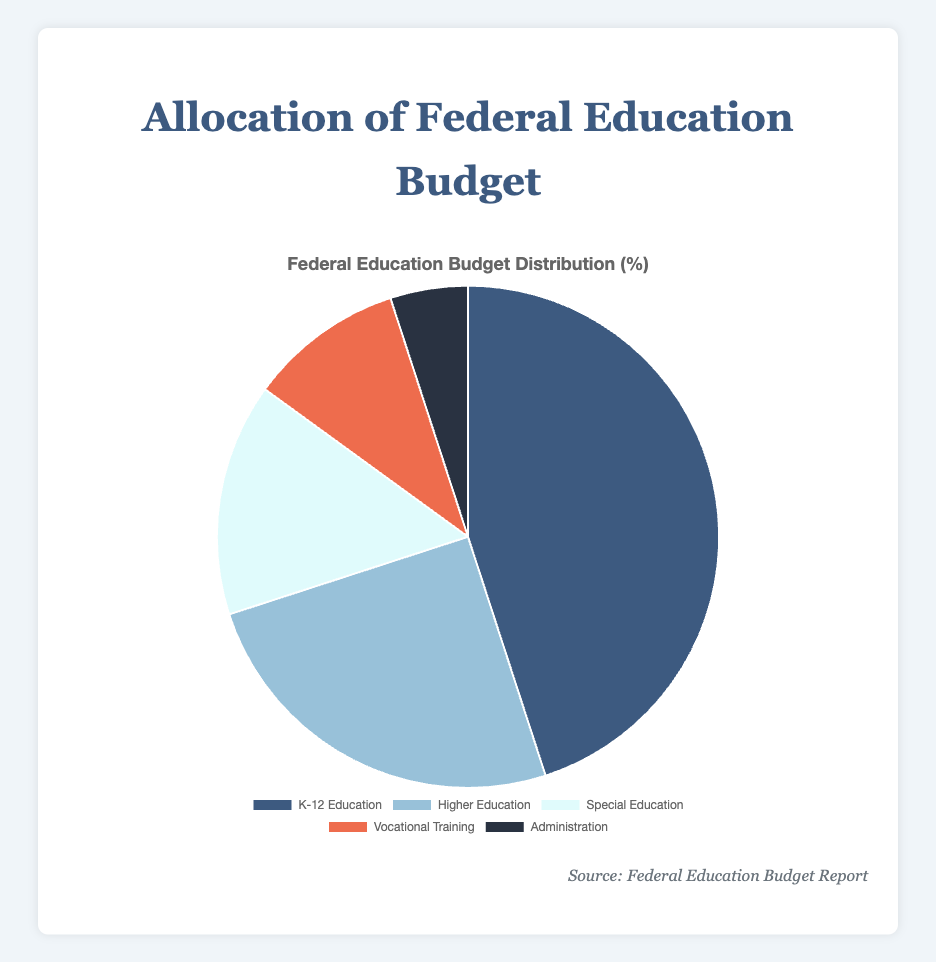What percentage of the budget is allocated to K-12 Education compared to Higher Education? K-12 Education has 45.0% of the budget, while Higher Education has 25.0%. Subtract 25.0 from 45.0, which equals 20.0%.
Answer: 20.0% How many total percentage points are allocated to Special Education and Vocational Training combined? Special Education has 15.0% and Vocational Training has 10.0%. Adding these together, 15.0 + 10.0 = 25.0%.
Answer: 25.0% Is there a category that represents less than 10% of the total budget? The Administration category represents 5.0% of the total budget. This is the only category with less than 10% of the budget.
Answer: Yes, Administration Which category has the smallest budget allocation and what is its percentage? The Administration category has the smallest budget allocation at 5.0%.
Answer: Administration with 5.0% What is the difference in percentage between the category with the largest and smallest allocations? K-12 Education has the largest allocation at 45.0% and Administration has the smallest at 5.0%. Subtract 5.0 from 45.0, resulting in 40.0%.
Answer: 40.0% If the budget were to increase the funding for Special Education by 5%, what would be the new percentage allocation for Special Education? Special Education currently has 15.0%. Increasing this by 5% results in 15.0 + 5.0 = 20.0%.
Answer: 20.0% Which category has the second highest allocation, and how does its percentage compare to the highest category? Higher Education has the second highest allocation at 25.0%, while K-12 Education has the highest at 45.0%. The difference is 45.0 - 25.0 = 20.0%.
Answer: Higher Education with 25.0%, 20.0% less than K-12 Education What are the combined percentages of all categories except K-12 Education? The percentages for Higher Education, Special Education, Vocational Training, and Administration are 25.0%, 15.0%, 10.0%, and 5.0%, respectively. Adding these, 25.0 + 15.0 + 10.0 + 5.0 = 55.0%.
Answer: 55.0% Which category appears in the lightest shade of blue, and what is its budget allocation percentage? The Vocational Training category appears in the lightest shade of blue, with a budget allocation percentage of 10.0%.
Answer: Vocational Training with 10.0% 